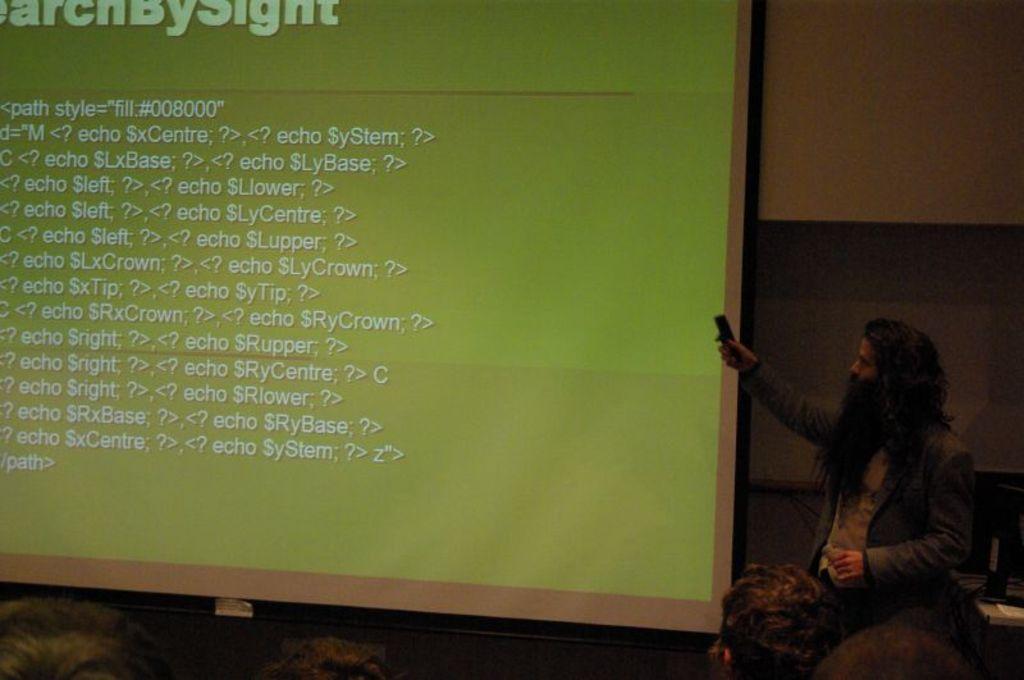Could you give a brief overview of what you see in this image? In this picture we can see a man holding an object. In front of the man there are groups of people. On the left side of the man there is a projector screen and behind the man there is a wall and other things. 